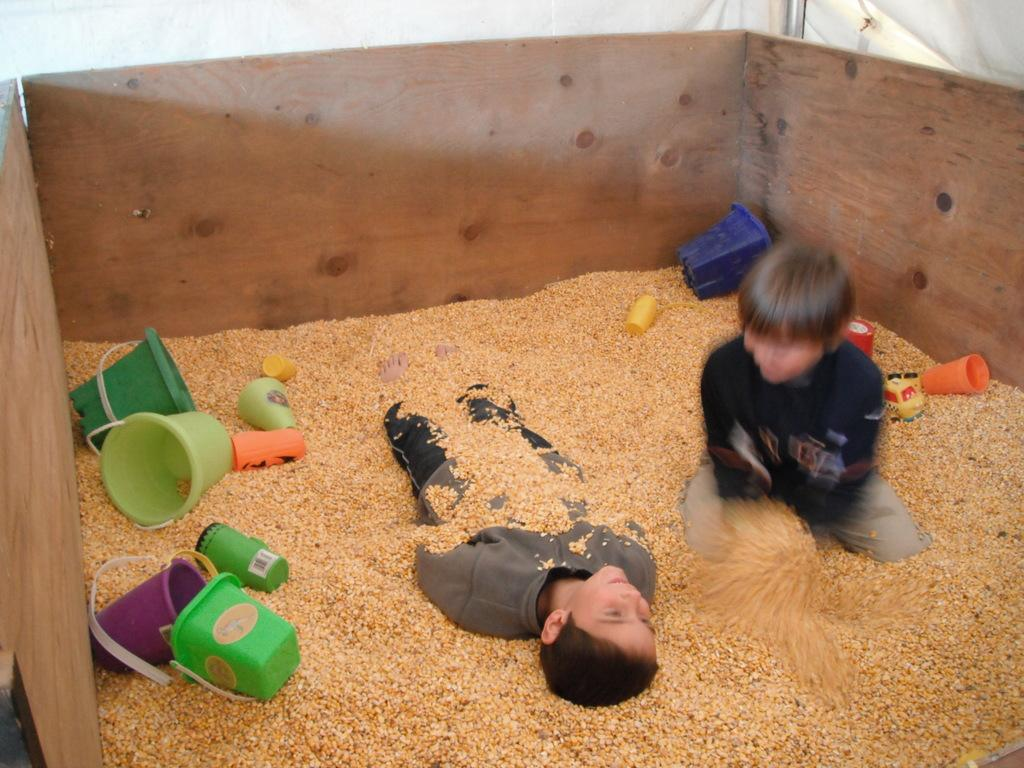What object is present in the image that can hold items? There is a box in the image that can hold items. What is inside the box in the image? The box contains sand. What other objects can be seen in the image? There are buckets and glasses in the image. Who is present in the image? There are kids in the image. What part of the brain can be seen in the image? There is no part of the brain present in the image. Are there any slaves depicted in the image? There is no mention of slaves in the image, and the presence of kids suggests a playful or casual setting. 